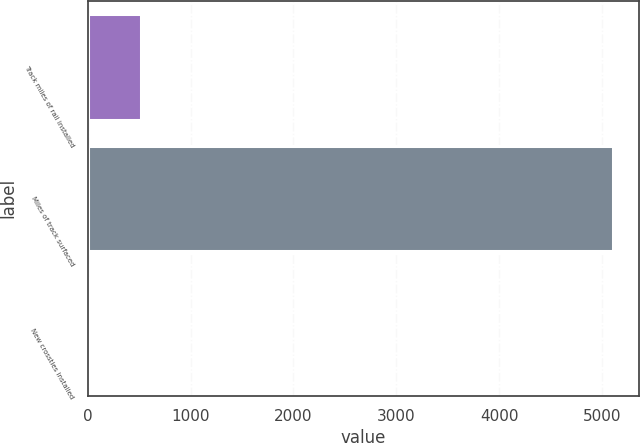Convert chart. <chart><loc_0><loc_0><loc_500><loc_500><bar_chart><fcel>Track miles of rail installed<fcel>Miles of track surfaced<fcel>New crossties installed<nl><fcel>513.02<fcel>5105<fcel>2.8<nl></chart> 